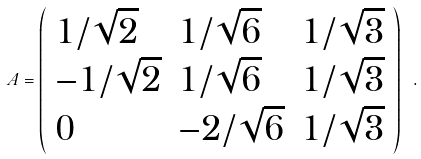Convert formula to latex. <formula><loc_0><loc_0><loc_500><loc_500>A = \left ( \begin{array} { l l l } { 1 / \sqrt { 2 } } & { 1 / \sqrt { 6 } } & { 1 / \sqrt { 3 } } \\ { - 1 / \sqrt { 2 } } & { 1 / \sqrt { 6 } } & { 1 / \sqrt { 3 } } \\ { 0 } & { - 2 / \sqrt { 6 } } & { 1 / \sqrt { 3 } } \end{array} \right ) \ .</formula> 